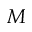<formula> <loc_0><loc_0><loc_500><loc_500>M</formula> 